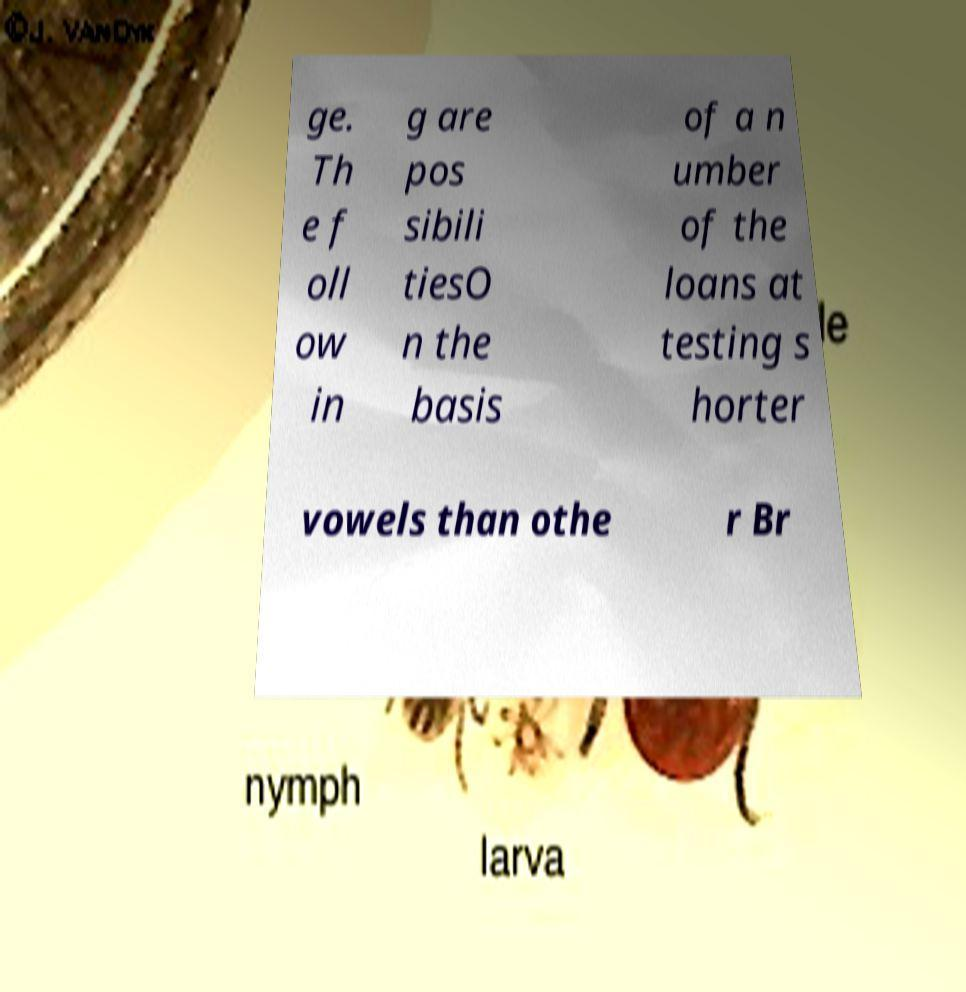I need the written content from this picture converted into text. Can you do that? ge. Th e f oll ow in g are pos sibili tiesO n the basis of a n umber of the loans at testing s horter vowels than othe r Br 